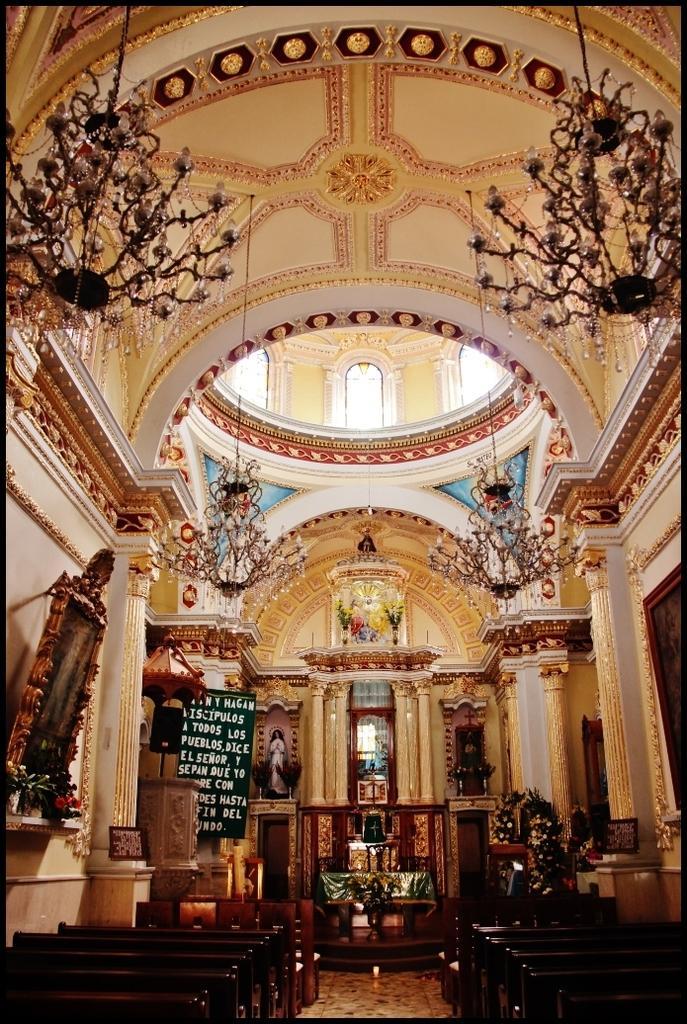Describe this image in one or two sentences. In the image we can see the inner view of the church, where we can see, pillars, benches, photo frames, boards, chandeliers. 